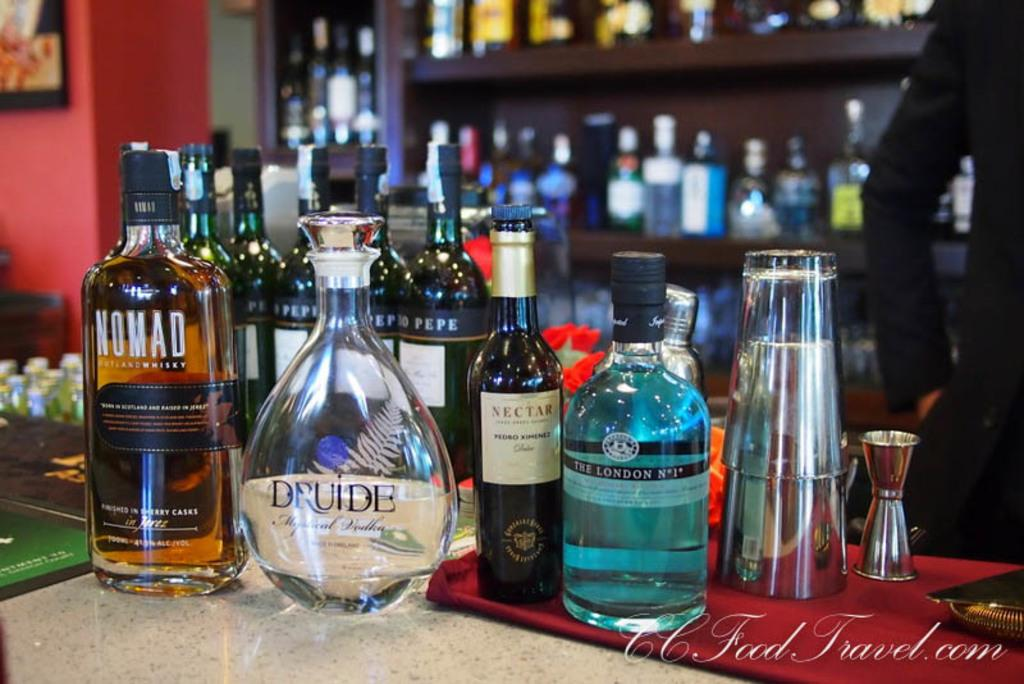Provide a one-sentence caption for the provided image. A selection of liquors at a bar includes a bottle of Nomad whiskey. 